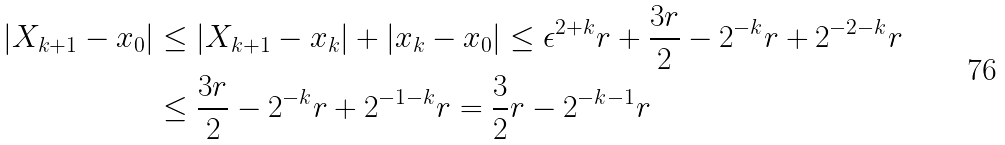Convert formula to latex. <formula><loc_0><loc_0><loc_500><loc_500>| X _ { k + 1 } - x _ { 0 } | & \leq | X _ { k + 1 } - x _ { k } | + | x _ { k } - x _ { 0 } | \leq \epsilon ^ { 2 + k } r + \frac { 3 r } { 2 } - 2 ^ { - k } r + 2 ^ { - 2 - k } r \\ & \leq \frac { 3 r } { 2 } - 2 ^ { - k } r + 2 ^ { - 1 - k } r = \frac { 3 } { 2 } r - 2 ^ { - k - 1 } r</formula> 